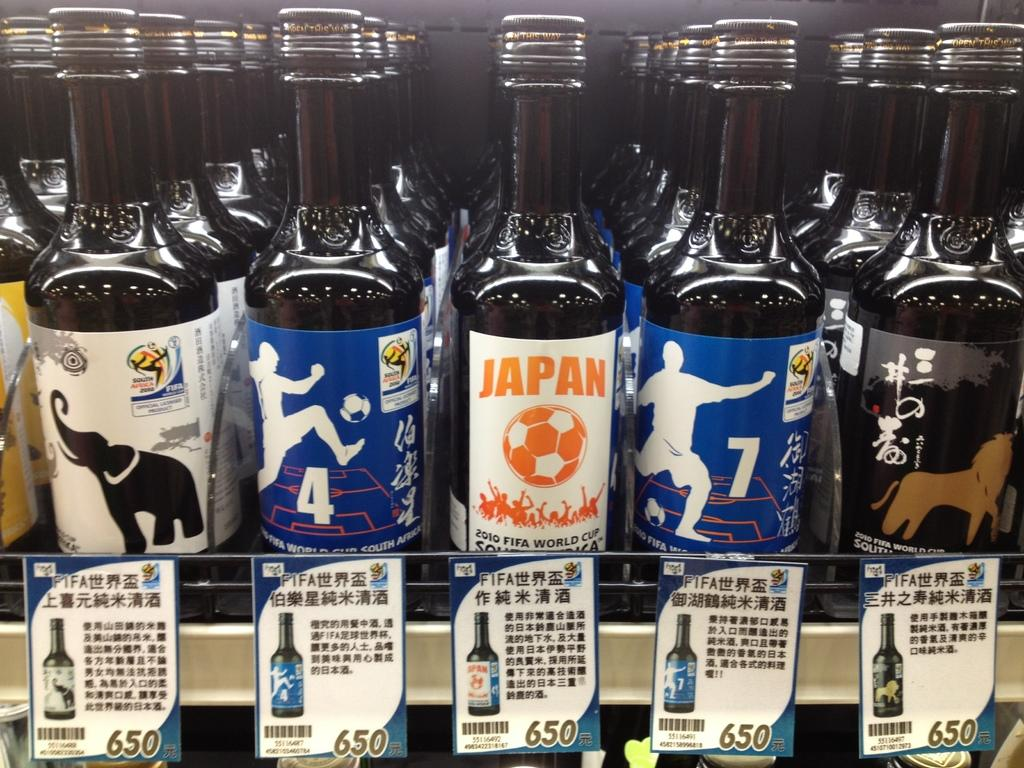<image>
Give a short and clear explanation of the subsequent image. A bottle of Japan costs 650 japanese yen 